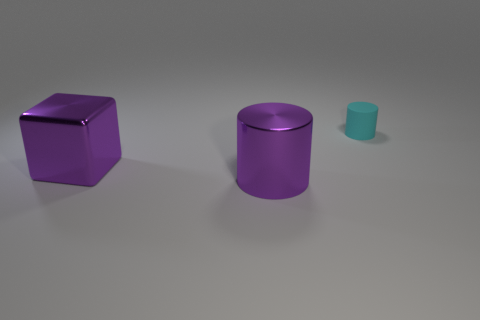Add 1 brown matte objects. How many objects exist? 4 Subtract all cylinders. How many objects are left? 1 Subtract all shiny things. Subtract all large purple cylinders. How many objects are left? 0 Add 1 big purple things. How many big purple things are left? 3 Add 2 tiny cyan rubber cylinders. How many tiny cyan rubber cylinders exist? 3 Subtract 0 brown balls. How many objects are left? 3 